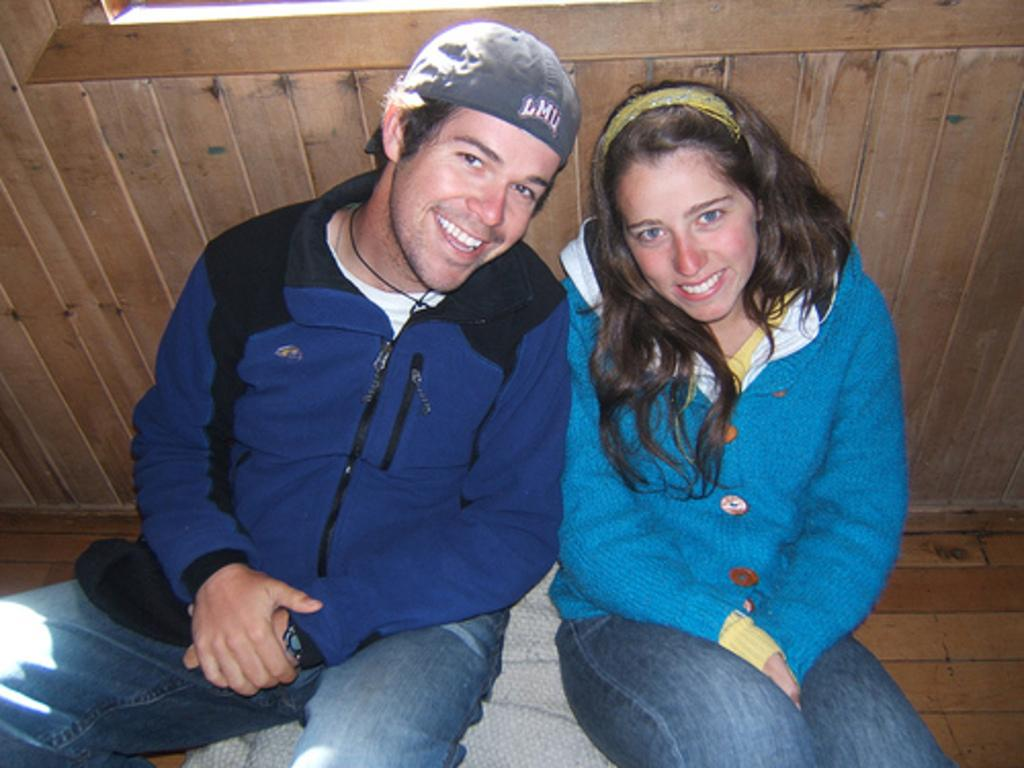How many people are in the image? There are two persons in the image. What are the two persons doing in the image? The two persons are sitting on an object and laughing. What might be the reason for their laughter? It is not clear from the image why they are laughing, but they could be enjoying each other's company or a shared experience. What is the wooden object behind the two persons? There is a wooden object behind the two persons, but its specific purpose or identity is not clear from the image. Can you see any crooks or deer in the garden in the image? There is no garden present in the image, and therefore no crooks or deer can be seen. 